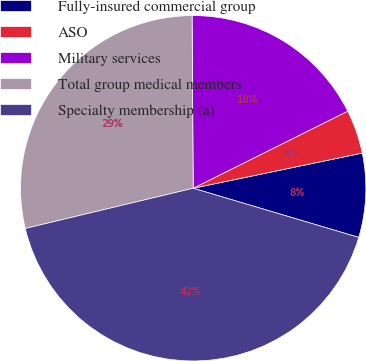<chart> <loc_0><loc_0><loc_500><loc_500><pie_chart><fcel>Fully-insured commercial group<fcel>ASO<fcel>Military services<fcel>Total group medical members<fcel>Specialty membership (a)<nl><fcel>7.86%<fcel>4.1%<fcel>17.74%<fcel>28.64%<fcel>41.67%<nl></chart> 